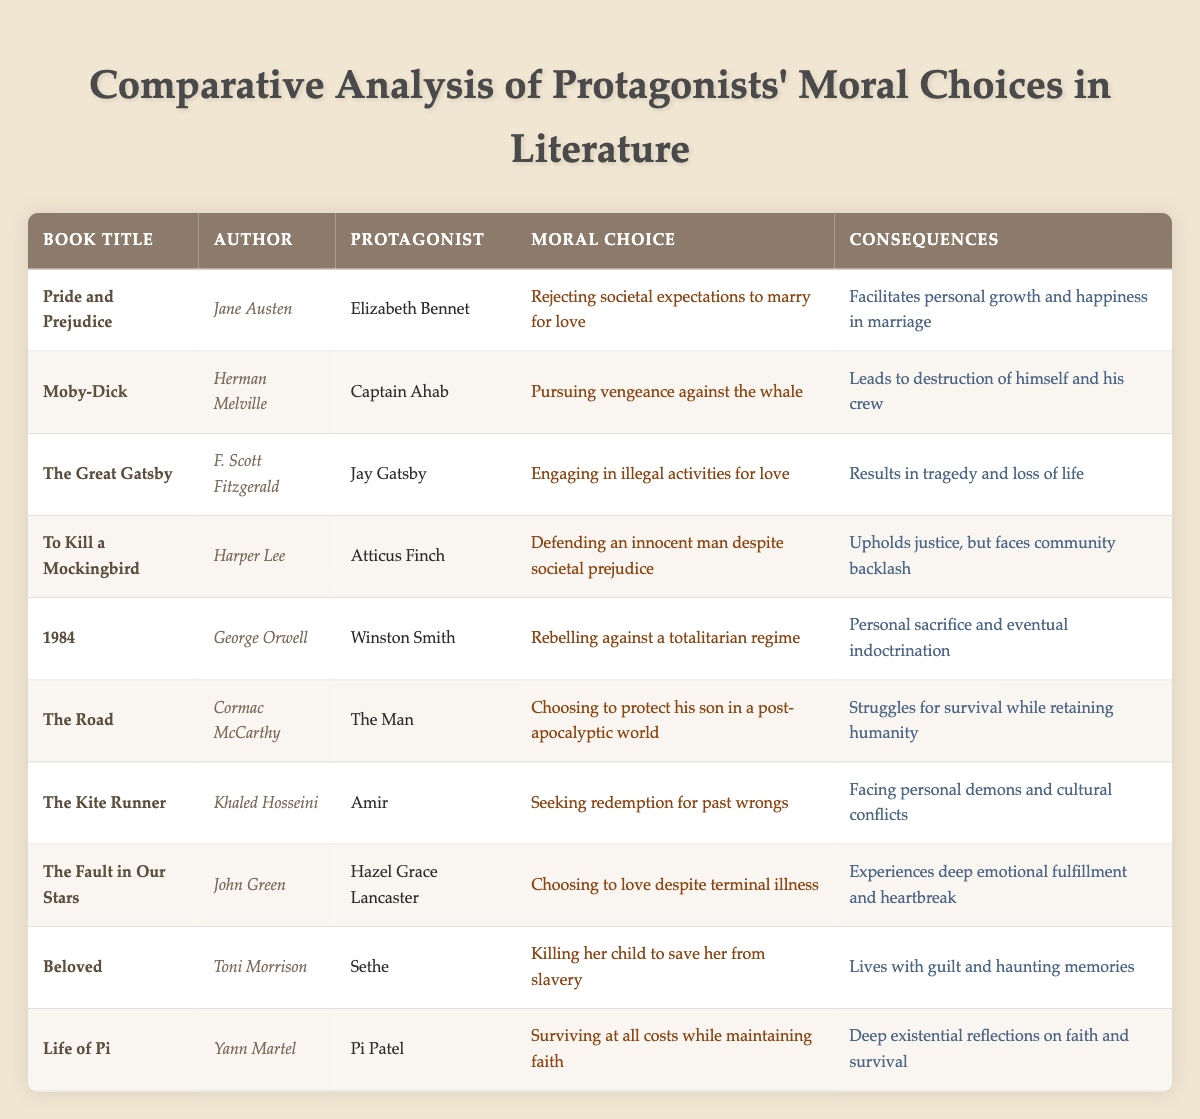What is the moral choice of Elizabeth Bennet in "Pride and Prejudice"? The table states that Elizabeth Bennet's moral choice is "Rejecting societal expectations to marry for love." This information can be found under the "Moral Choice" column associated with "Pride and Prejudice."
Answer: Rejecting societal expectations to marry for love Who wrote "To Kill a Mockingbird"? The author of "To Kill a Mockingbird" is listed in the table as Harper Lee. This can be directly retrieved from the "Author" column corresponding to the book title.
Answer: Harper Lee Which protagonist is involved in a tragic consequence due to illegal activities? The protagonist Jay Gatsby from "The Great Gatsby" engages in illegal activities for love, which leads to tragedy and loss of life. These details are found in the respective columns of the table.
Answer: Jay Gatsby Did Winston Smith from "1984" rebel against a totalitarian regime? According to the table, Winston Smith's moral choice is described as "Rebelling against a totalitarian regime," indicating that the statement is true.
Answer: Yes What is the primary consequence faced by Sethe in "Beloved"? The table indicates that Sethe’s moral choice involves killing her child to save her from slavery, which results in living with guilt and haunting memories. This information is noted in the "Consequences" column next to Sethe.
Answer: Lives with guilt and haunting memories What moral choices lead to personal growth and happiness in marriage? The table lists Elizabeth Bennet’s choice of rejecting societal expectations to marry for love as resulting in personal growth and happiness, which fulfills the question requirements.
Answer: Rejecting societal expectations to marry for love Which two protagonists face community backlash for their moral choices? From the table, Atticus Finch from "To Kill a Mockingbird" faces community backlash for defending an innocent man, and Elizabeth Bennet experiences societal pressures for her choice in marriage. Both are mentioned in the "Consequences" column relating to their moral choices.
Answer: Atticus Finch and Elizabeth Bennet What are two contrasting consequences of moral choices depicted in classic versus contemporary literature? The table shows that classic literature characters like Ahab, whose revenge leads to self-destruction, contrast with contemporary characters like The Man in "The Road," whose choice to protect his son leads to a struggle for survival while maintaining humanity. This highlights the differences in consequence perspective across time periods.
Answer: Self-destruction vs. struggle for survival 